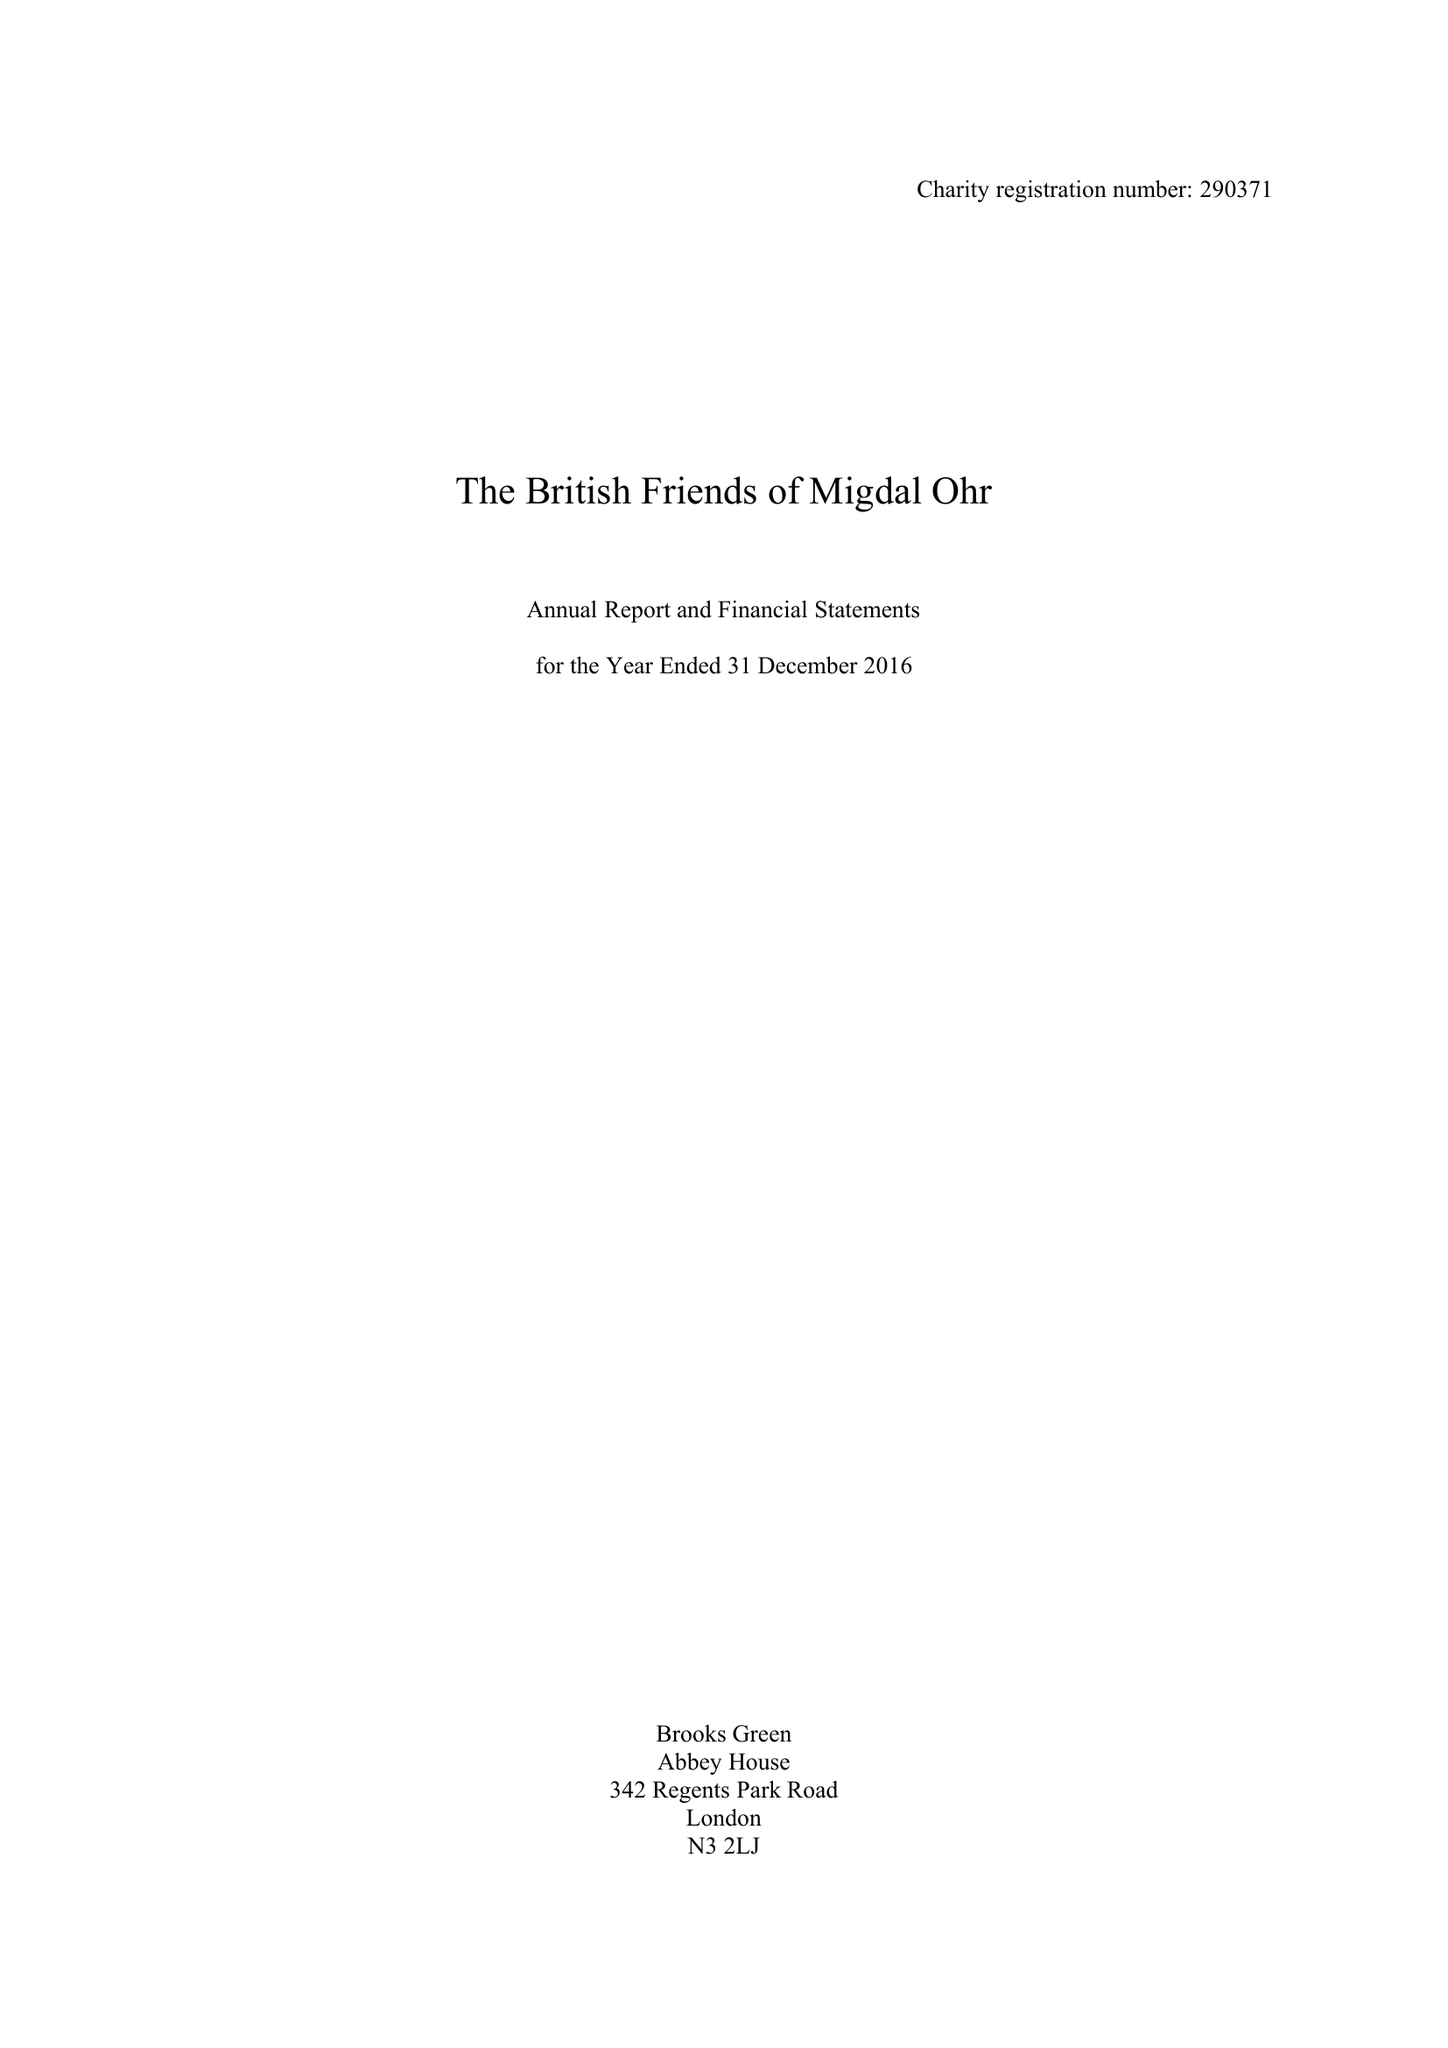What is the value for the income_annually_in_british_pounds?
Answer the question using a single word or phrase. 703841.00 